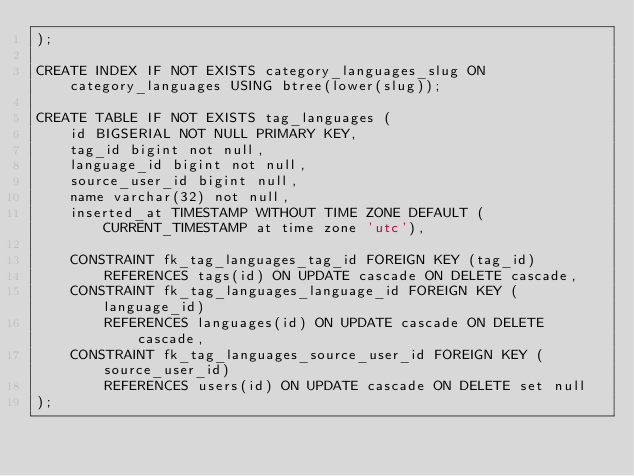Convert code to text. <code><loc_0><loc_0><loc_500><loc_500><_SQL_>);

CREATE INDEX IF NOT EXISTS category_languages_slug ON category_languages USING btree(lower(slug));

CREATE TABLE IF NOT EXISTS tag_languages (
    id BIGSERIAL NOT NULL PRIMARY KEY,
    tag_id bigint not null,
    language_id bigint not null,
    source_user_id bigint null,
    name varchar(32) not null,
    inserted_at TIMESTAMP WITHOUT TIME ZONE DEFAULT (CURRENT_TIMESTAMP at time zone 'utc'),

    CONSTRAINT fk_tag_languages_tag_id FOREIGN KEY (tag_id)
        REFERENCES tags(id) ON UPDATE cascade ON DELETE cascade,
    CONSTRAINT fk_tag_languages_language_id FOREIGN KEY (language_id)
        REFERENCES languages(id) ON UPDATE cascade ON DELETE cascade,
    CONSTRAINT fk_tag_languages_source_user_id FOREIGN KEY (source_user_id)
        REFERENCES users(id) ON UPDATE cascade ON DELETE set null
);</code> 